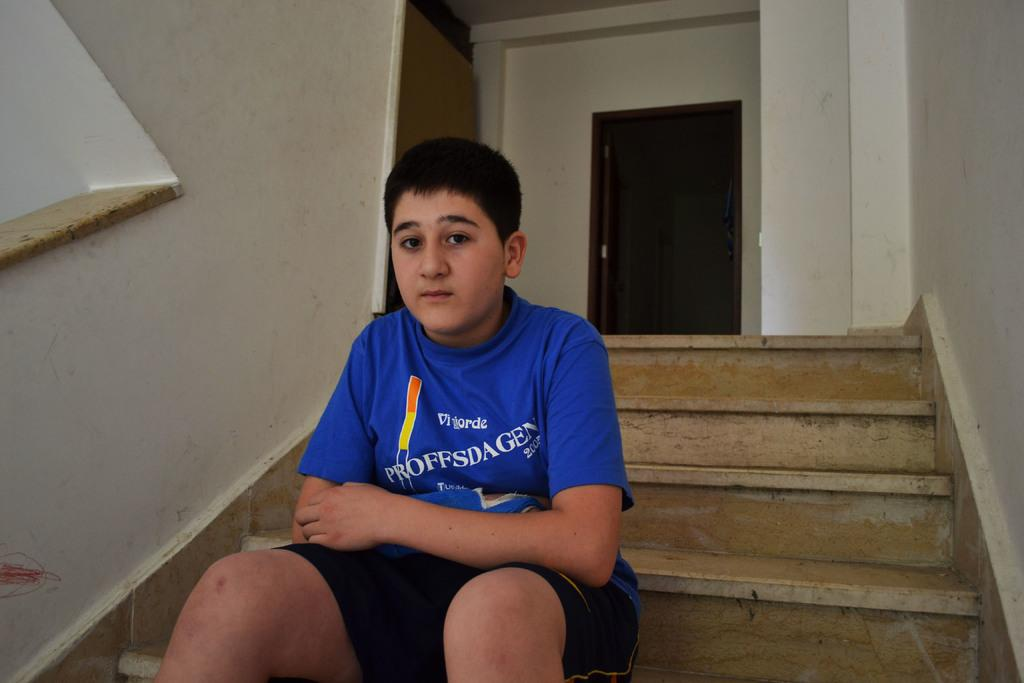Provide a one-sentence caption for the provided image. A boy in a blue shirt that says Proffsdagen is sitting on steps. 